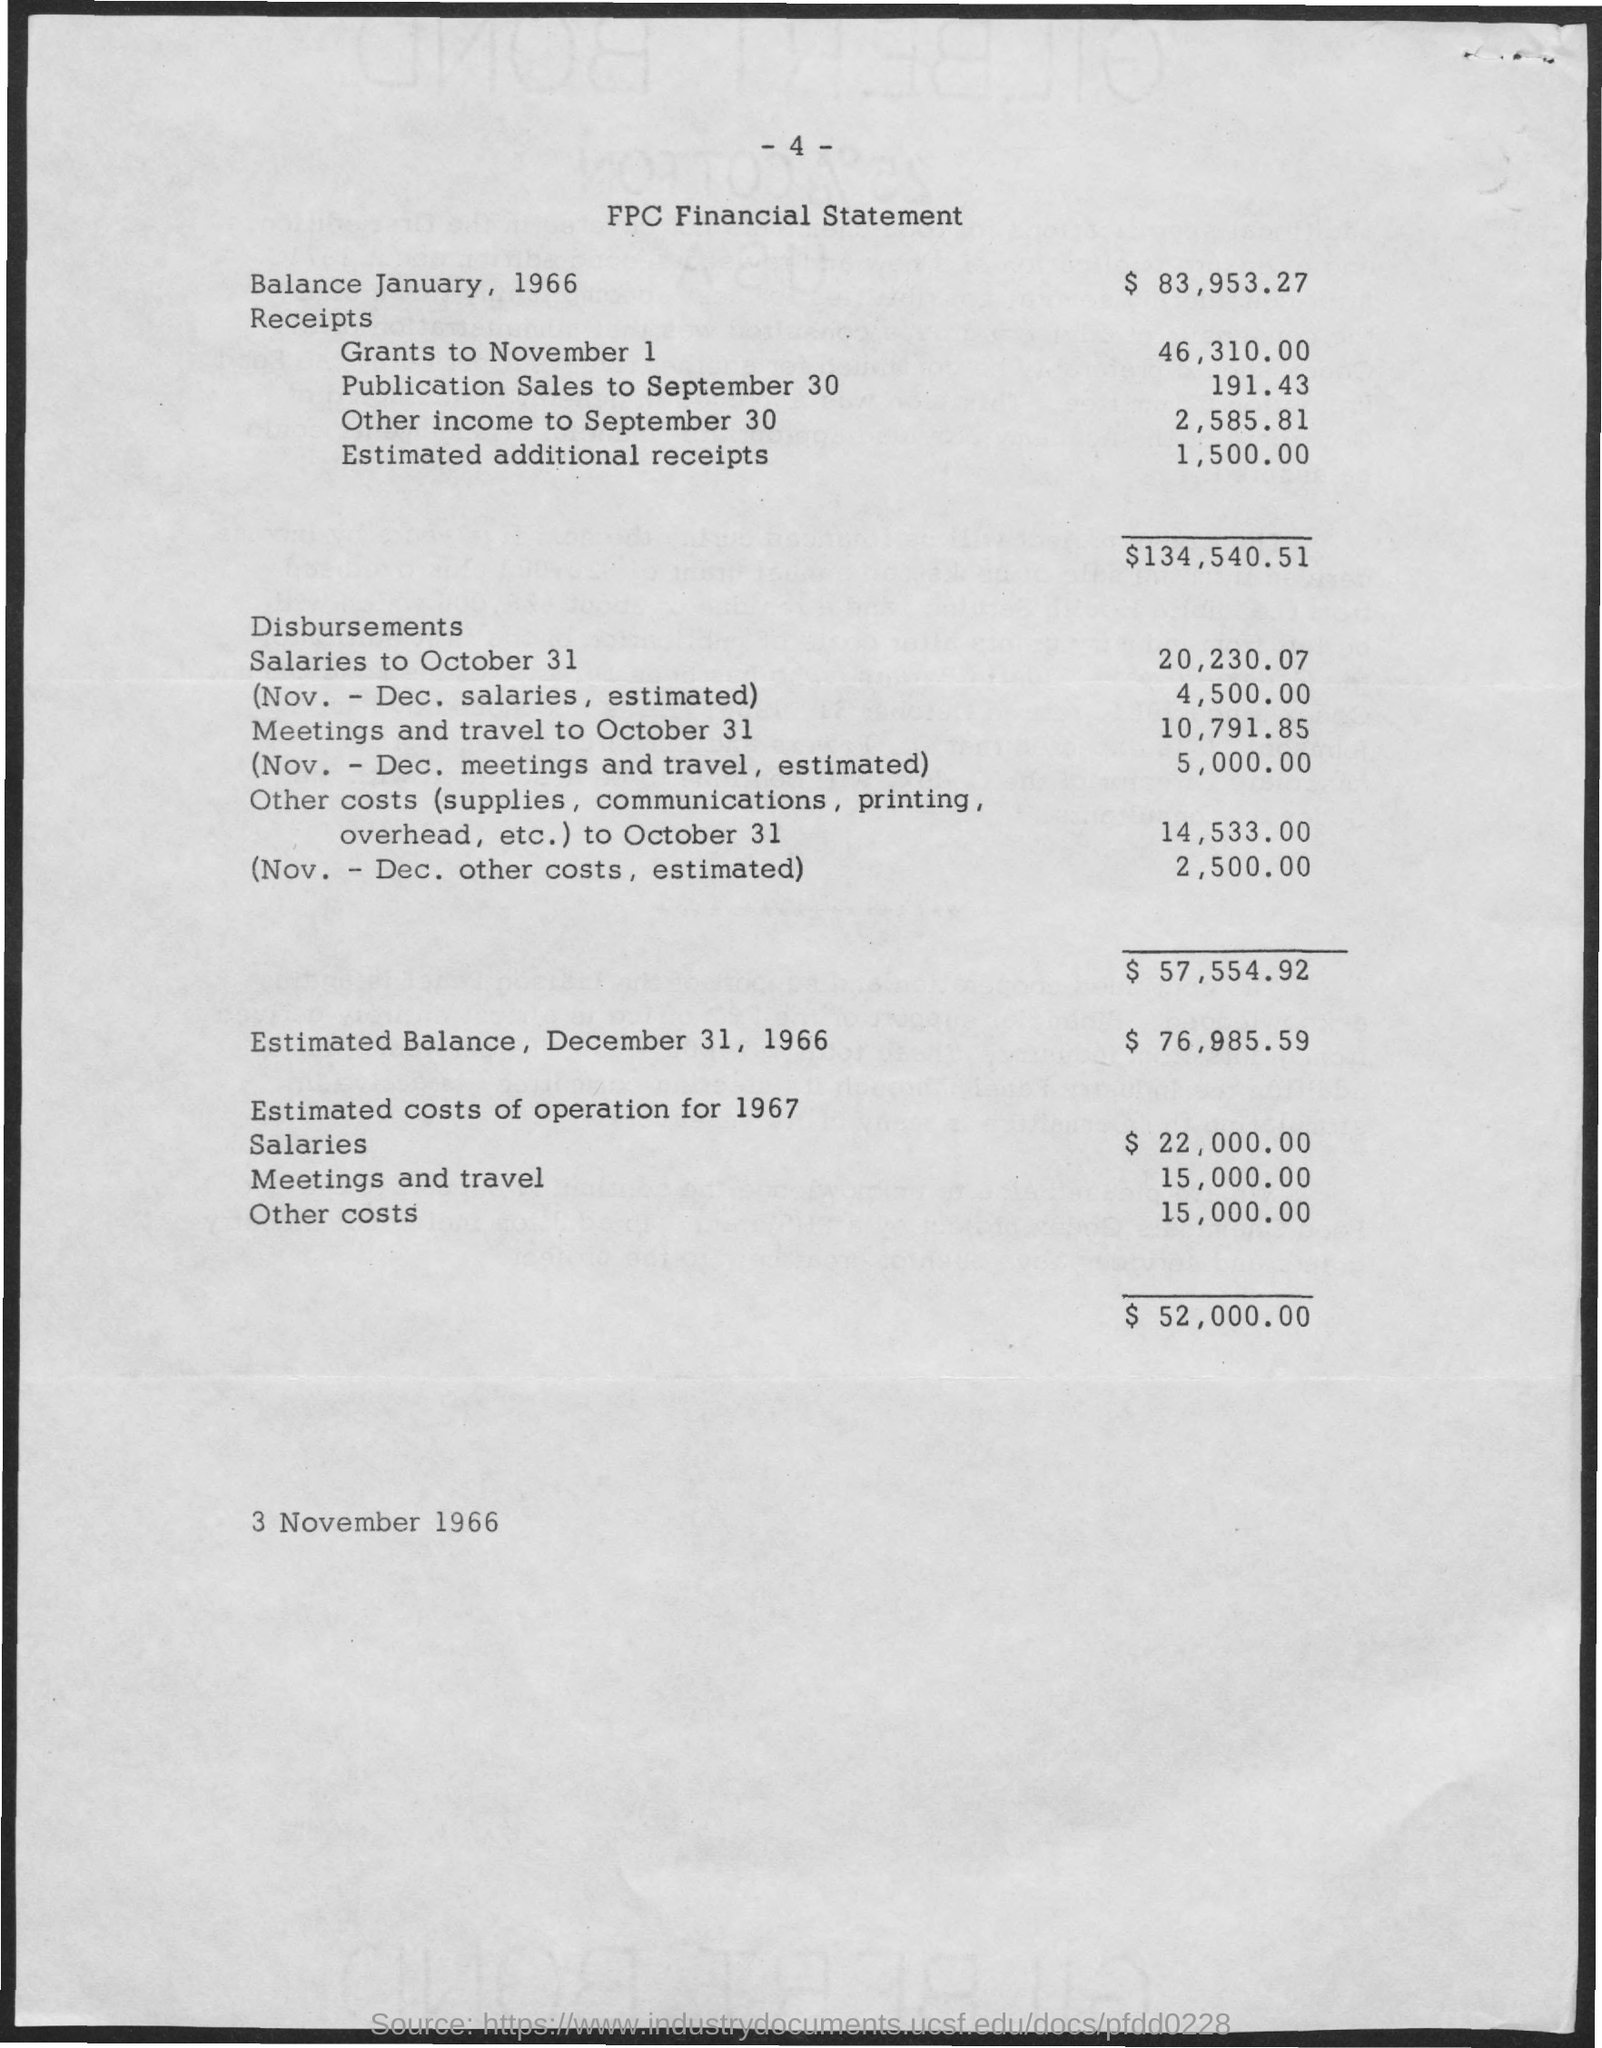Specify some key components in this picture. The estimated cost of operation for meetings and travel in 1966 was $15,000.00. What are the estimated additional receipts? They are estimated to be 1,500,000... The value of 'receipts' for 'grants to november' 1 is 46,310.00. The estimated cost of salaries for 1966 was 22,000.00. As of January 1966, the balance was 83,953.27. 